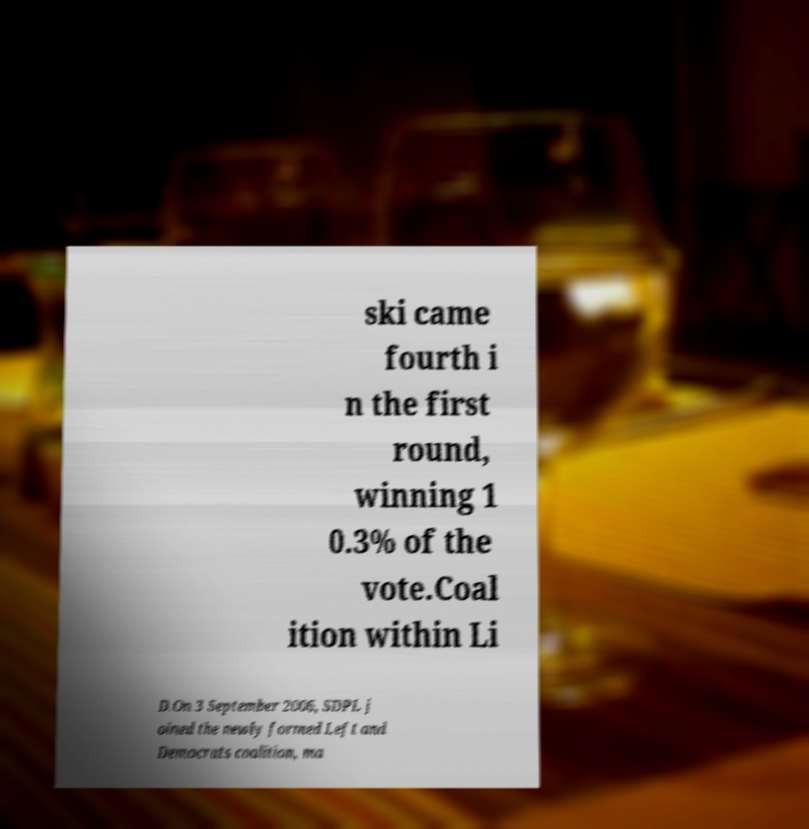There's text embedded in this image that I need extracted. Can you transcribe it verbatim? ski came fourth i n the first round, winning 1 0.3% of the vote.Coal ition within Li D.On 3 September 2006, SDPL j oined the newly formed Left and Democrats coalition, ma 